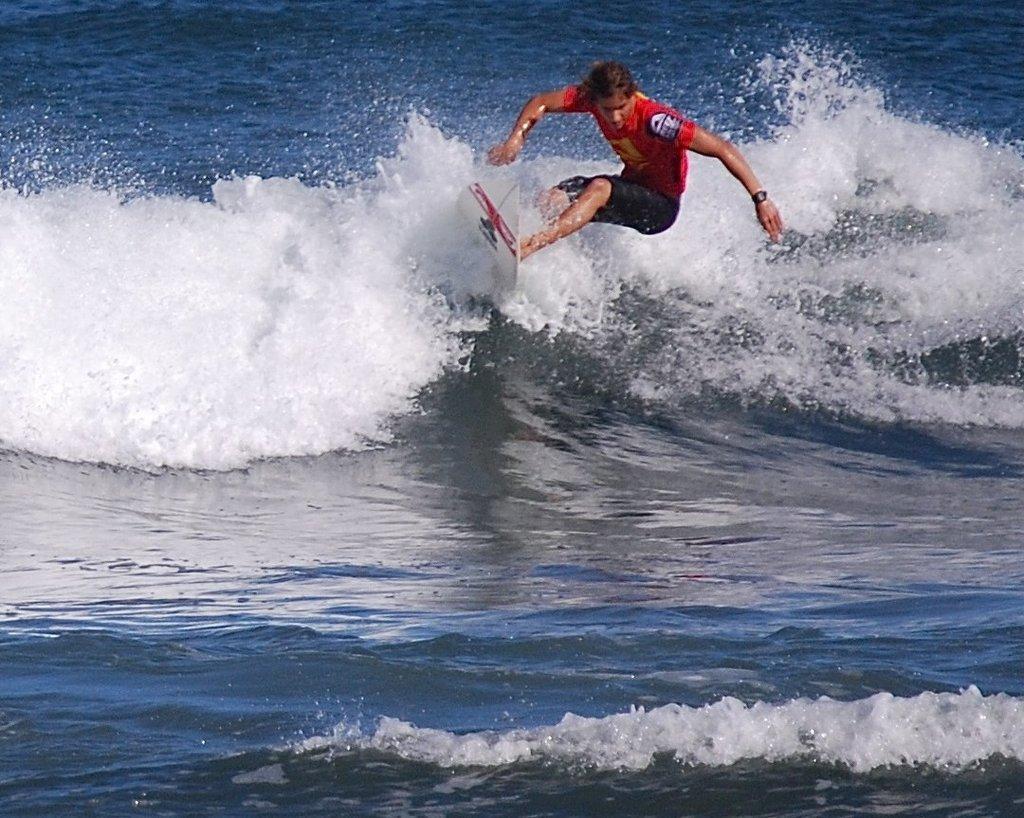In one or two sentences, can you explain what this image depicts? In this image I can see in the middle a person is surfing in the sea, this person is wearing a red color t-shirt, black color short. 